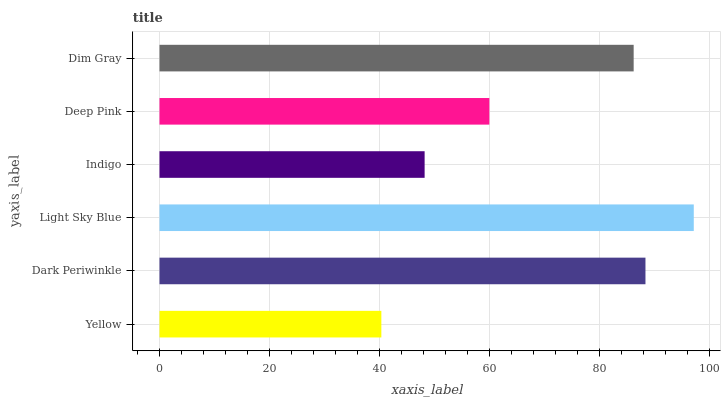Is Yellow the minimum?
Answer yes or no. Yes. Is Light Sky Blue the maximum?
Answer yes or no. Yes. Is Dark Periwinkle the minimum?
Answer yes or no. No. Is Dark Periwinkle the maximum?
Answer yes or no. No. Is Dark Periwinkle greater than Yellow?
Answer yes or no. Yes. Is Yellow less than Dark Periwinkle?
Answer yes or no. Yes. Is Yellow greater than Dark Periwinkle?
Answer yes or no. No. Is Dark Periwinkle less than Yellow?
Answer yes or no. No. Is Dim Gray the high median?
Answer yes or no. Yes. Is Deep Pink the low median?
Answer yes or no. Yes. Is Light Sky Blue the high median?
Answer yes or no. No. Is Dim Gray the low median?
Answer yes or no. No. 